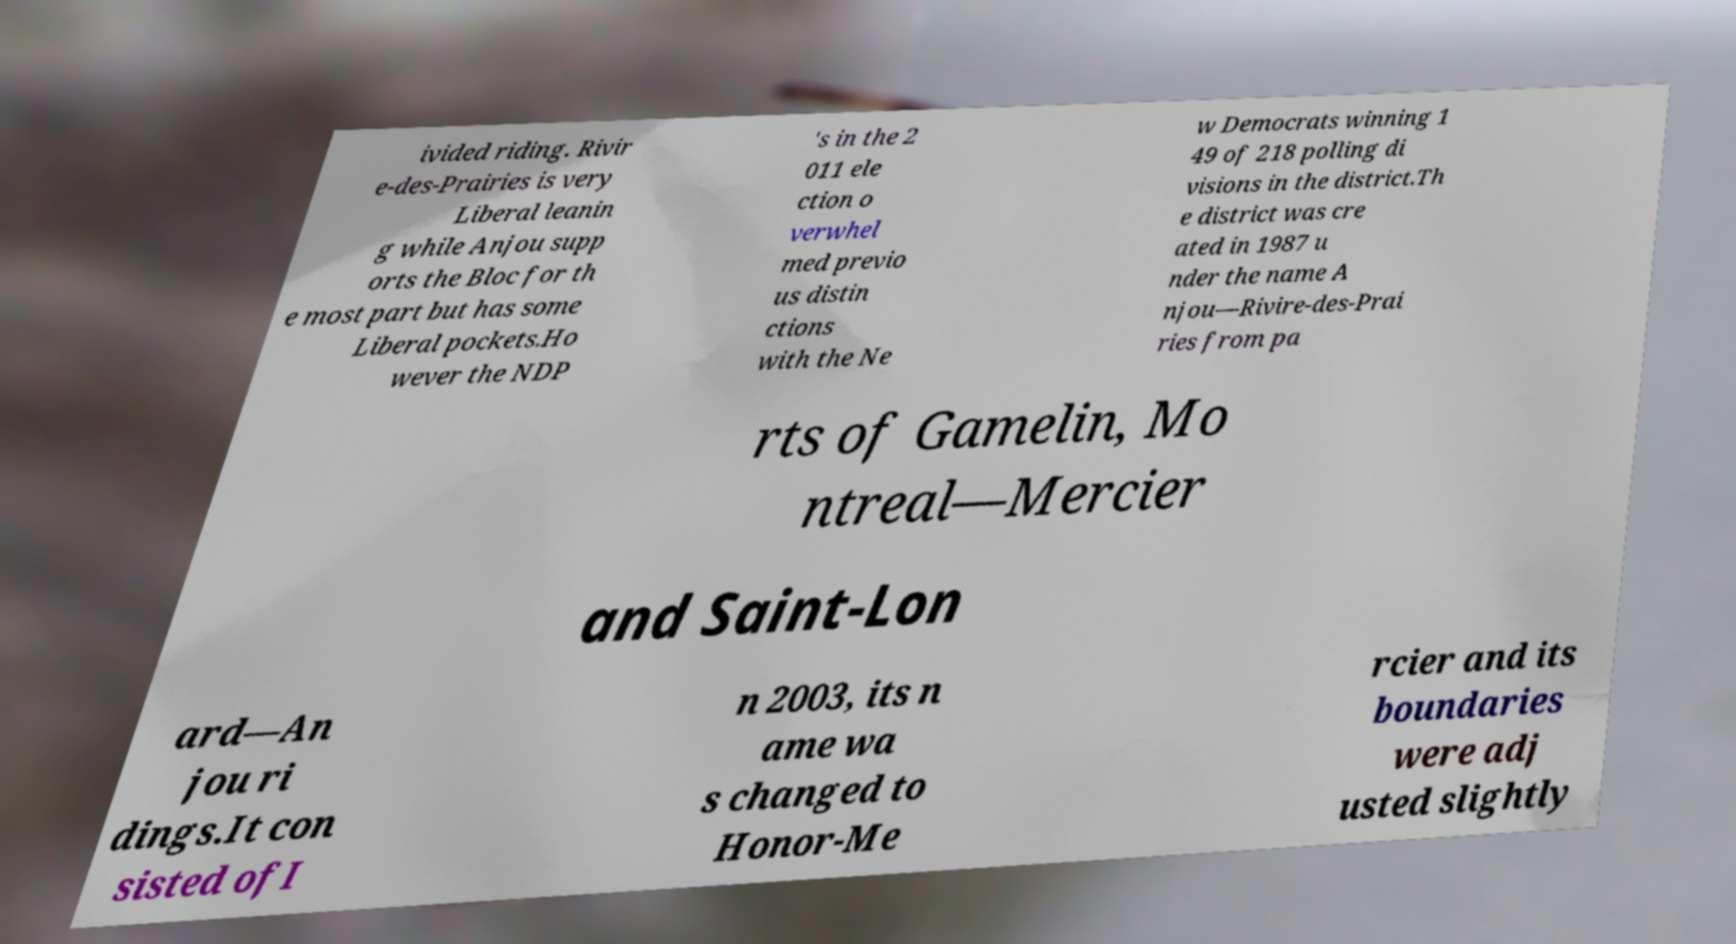Could you assist in decoding the text presented in this image and type it out clearly? ivided riding. Rivir e-des-Prairies is very Liberal leanin g while Anjou supp orts the Bloc for th e most part but has some Liberal pockets.Ho wever the NDP 's in the 2 011 ele ction o verwhel med previo us distin ctions with the Ne w Democrats winning 1 49 of 218 polling di visions in the district.Th e district was cre ated in 1987 u nder the name A njou—Rivire-des-Prai ries from pa rts of Gamelin, Mo ntreal—Mercier and Saint-Lon ard—An jou ri dings.It con sisted ofI n 2003, its n ame wa s changed to Honor-Me rcier and its boundaries were adj usted slightly 